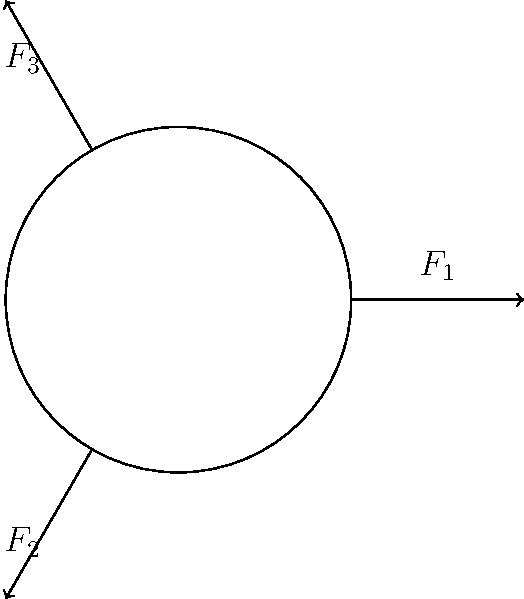In the structural design of Deep Space Nine, the station's weight is distributed across three pylons arranged at 120° angles. If the total weight of the station is 900,000 metric tons and the pylons are identical, calculate the force $F$ exerted on each pylon, assuming an even distribution of weight. To solve this problem, we'll use principles of force equilibrium in a symmetrical system:

1) The total weight of the station is 900,000 metric tons. In newtons, this is:
   $W = 900,000 \times 1000 \times 9.81 = 8.829 \times 10^9$ N

2) Since the pylons are arranged symmetrically at 120° angles, each pylon will bear an equal share of the total weight.

3) The force on each pylon ($F$) will be oriented 120° from the others. In a balanced system, the vertical components of these forces must sum to the total weight of the station.

4) The vertical component of each force is $F \cos(30°)$, as 30° is the complement of the 60° angle between each pylon and the vertical axis.

5) The equation for equilibrium is:
   $3F \cos(30°) = W$

6) Solving for $F$:
   $F = \frac{W}{3 \cos(30°)}$

7) Substituting the values:
   $F = \frac{8.829 \times 10^9}{3 \cos(30°)} = \frac{8.829 \times 10^9}{3 \times 0.866} = 3.397 \times 10^9$ N

8) Converting back to metric tons:
   $F = \frac{3.397 \times 10^9}{9.81 \times 1000} \approx 346,280$ metric tons

Therefore, each pylon must support approximately 346,280 metric tons.
Answer: 346,280 metric tons 